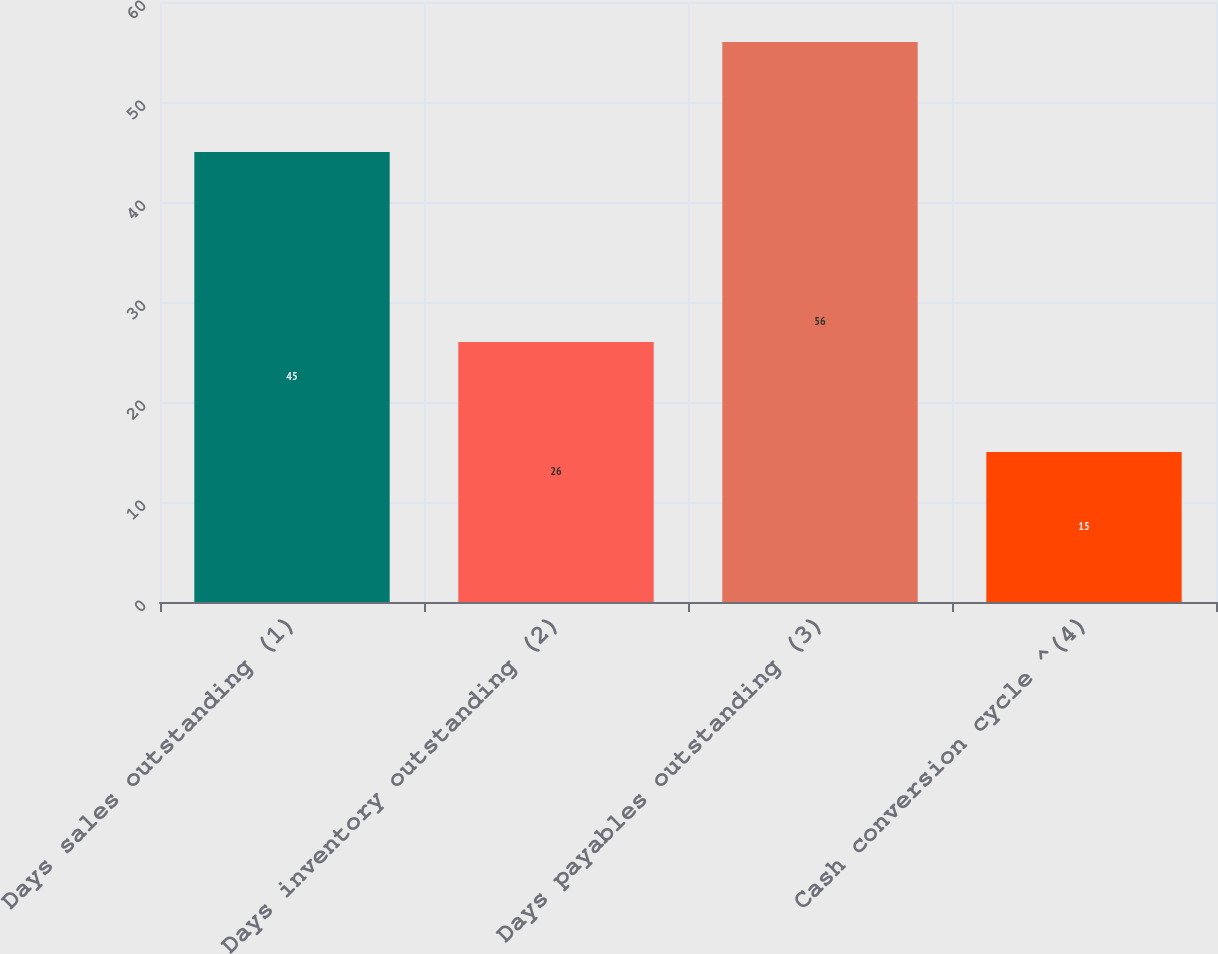Convert chart to OTSL. <chart><loc_0><loc_0><loc_500><loc_500><bar_chart><fcel>Days sales outstanding (1)<fcel>Days inventory outstanding (2)<fcel>Days payables outstanding (3)<fcel>Cash conversion cycle ^(4)<nl><fcel>45<fcel>26<fcel>56<fcel>15<nl></chart> 